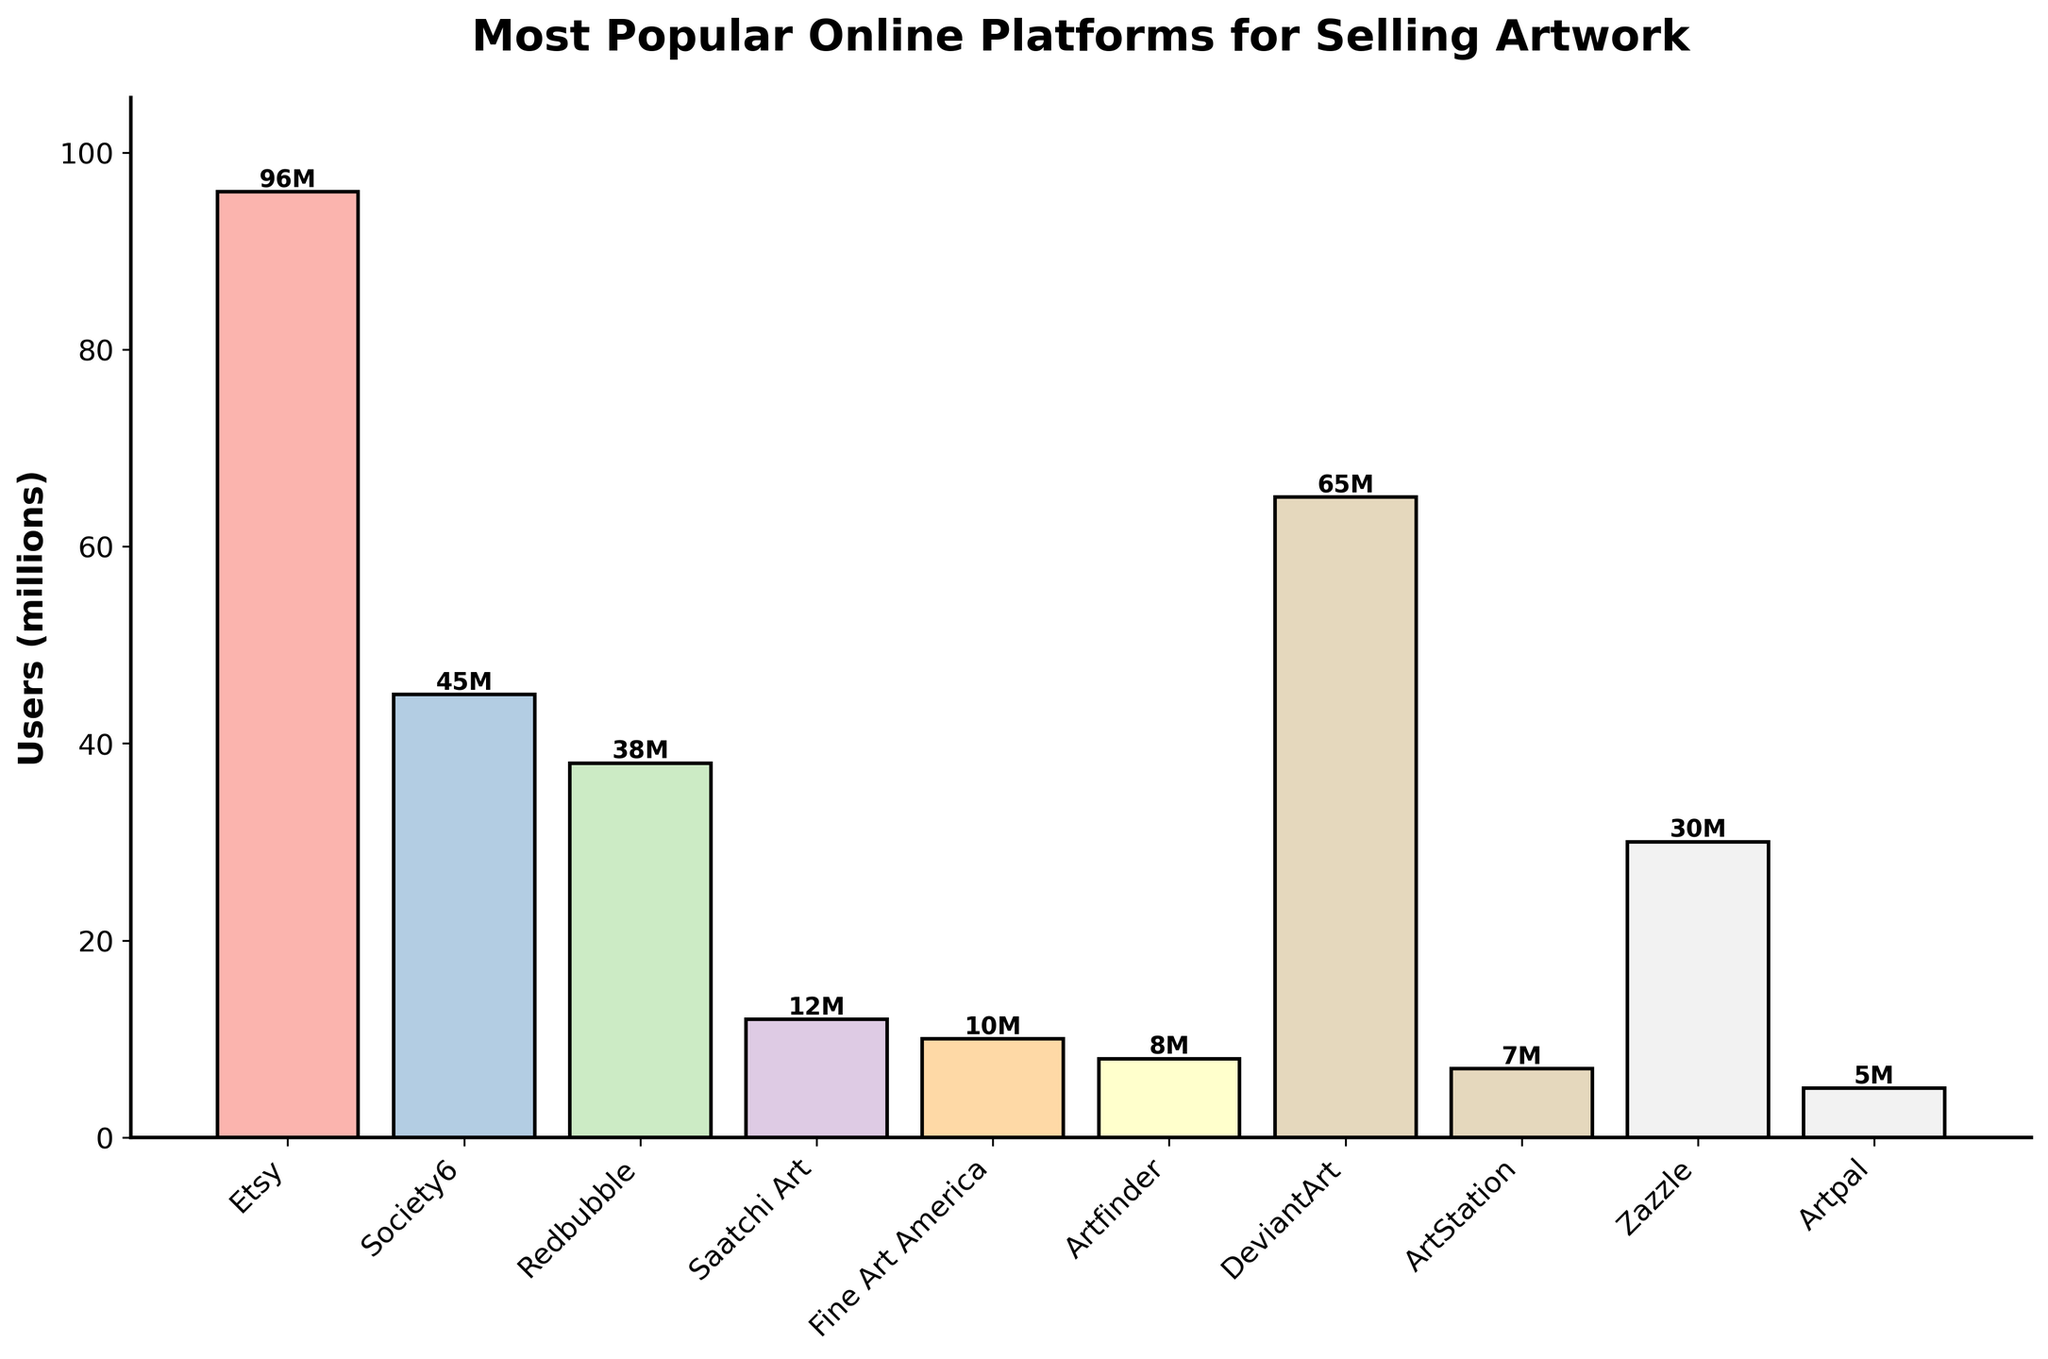Which platform has the highest user base? The tallest bar in the figure represents the platform with the highest user base. In this case, it is Etsy with 96 million users.
Answer: Etsy Which platform has the lowest user base? The shortest bar in the figure represents the platform with the lowest user base. In this case, it is Artpal with 5 million users.
Answer: Artpal How many users do Etsy, Society6, and Redbubble have combined? Sum the users of Etsy (96M), Society6 (45M), and Redbubble (38M): 96 + 45 + 38 = 179 million.
Answer: 179 million What is the average user base of all the platforms represented in the chart? Add up all the users of the platforms and divide by the number of platforms: (96 + 45 + 38 + 12 + 10 + 8 + 65 + 7 + 30 + 5) / 10 = 31.6 million.
Answer: 31.6 million Which platforms have more than 30 million users? Identify the platforms where the bar height exceeds 30 million users. These platforms are Etsy (96M), Society6 (45M), DeviantArt (65M), and Redbubble (38M).
Answer: Etsy, Society6, DeviantArt, Redbubble How many more users does Etsy have compared to Fine Art America? Subtract the users of Fine Art America (10M) from Etsy (96M): 96 - 10 = 86 million.
Answer: 86 million Which platform has more users: Artfinder or ArtStation? Compare the heights of the bars for Artfinder and ArtStation. Artfinder (8M) has more users than ArtStation (7M).
Answer: Artfinder What is the total user base of the five least popular platforms? Sum the users of the five platforms with the shortest bars: Saatchi Art (12M), Fine Art America (10M), Artfinder (8M), ArtStation (7M), Artpal (5M). 12 + 10 + 8 + 7 + 5 = 42 million.
Answer: 42 million By how many users does Redbubble surpass Zazzle? Subtract the users of Zazzle (30M) from Redbubble (38M): 38 - 30 = 8 million.
Answer: 8 million 